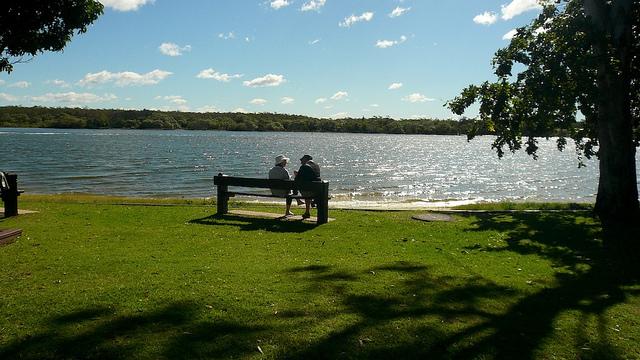How many benches are in the scene?
Quick response, please. 1. What kind of shoreline is this?
Be succinct. Lake. What are the people on the bench looking at?
Concise answer only. Water. 